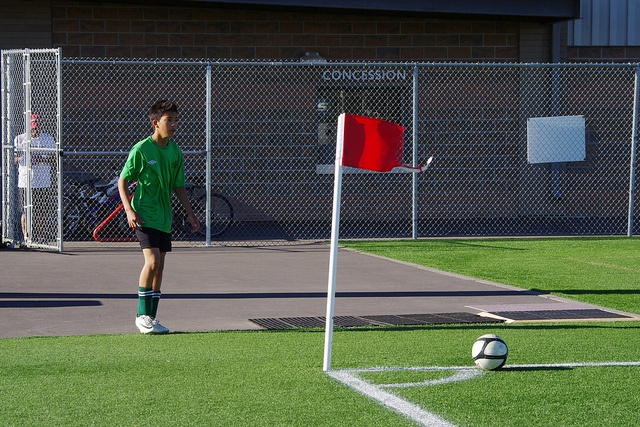Describe the objects in this image and their specific colors. I can see people in black, darkgreen, maroon, and ivory tones, people in black, darkgray, gray, and lightgray tones, bicycle in black, gray, darkgray, and navy tones, bicycle in black, gray, and darkgray tones, and sports ball in black, white, and gray tones in this image. 